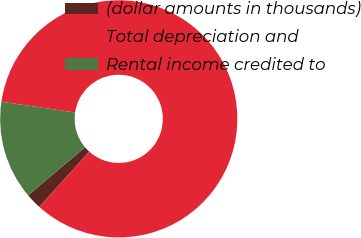Convert chart to OTSL. <chart><loc_0><loc_0><loc_500><loc_500><pie_chart><fcel>(dollar amounts in thousands)<fcel>Total depreciation and<fcel>Rental income credited to<nl><fcel>2.16%<fcel>84.38%<fcel>13.46%<nl></chart> 